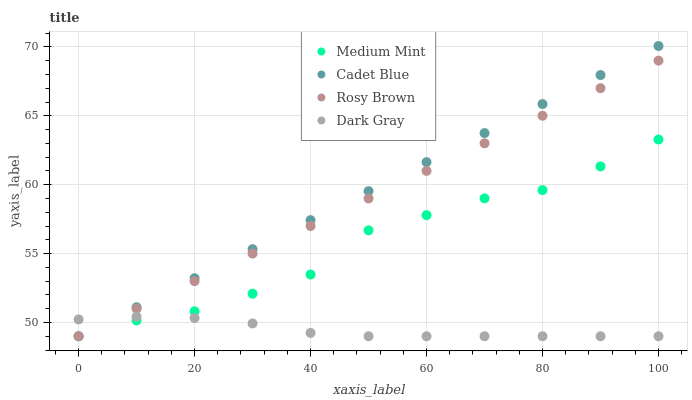Does Dark Gray have the minimum area under the curve?
Answer yes or no. Yes. Does Cadet Blue have the maximum area under the curve?
Answer yes or no. Yes. Does Rosy Brown have the minimum area under the curve?
Answer yes or no. No. Does Rosy Brown have the maximum area under the curve?
Answer yes or no. No. Is Cadet Blue the smoothest?
Answer yes or no. Yes. Is Medium Mint the roughest?
Answer yes or no. Yes. Is Dark Gray the smoothest?
Answer yes or no. No. Is Dark Gray the roughest?
Answer yes or no. No. Does Medium Mint have the lowest value?
Answer yes or no. Yes. Does Cadet Blue have the highest value?
Answer yes or no. Yes. Does Rosy Brown have the highest value?
Answer yes or no. No. Does Rosy Brown intersect Medium Mint?
Answer yes or no. Yes. Is Rosy Brown less than Medium Mint?
Answer yes or no. No. Is Rosy Brown greater than Medium Mint?
Answer yes or no. No. 